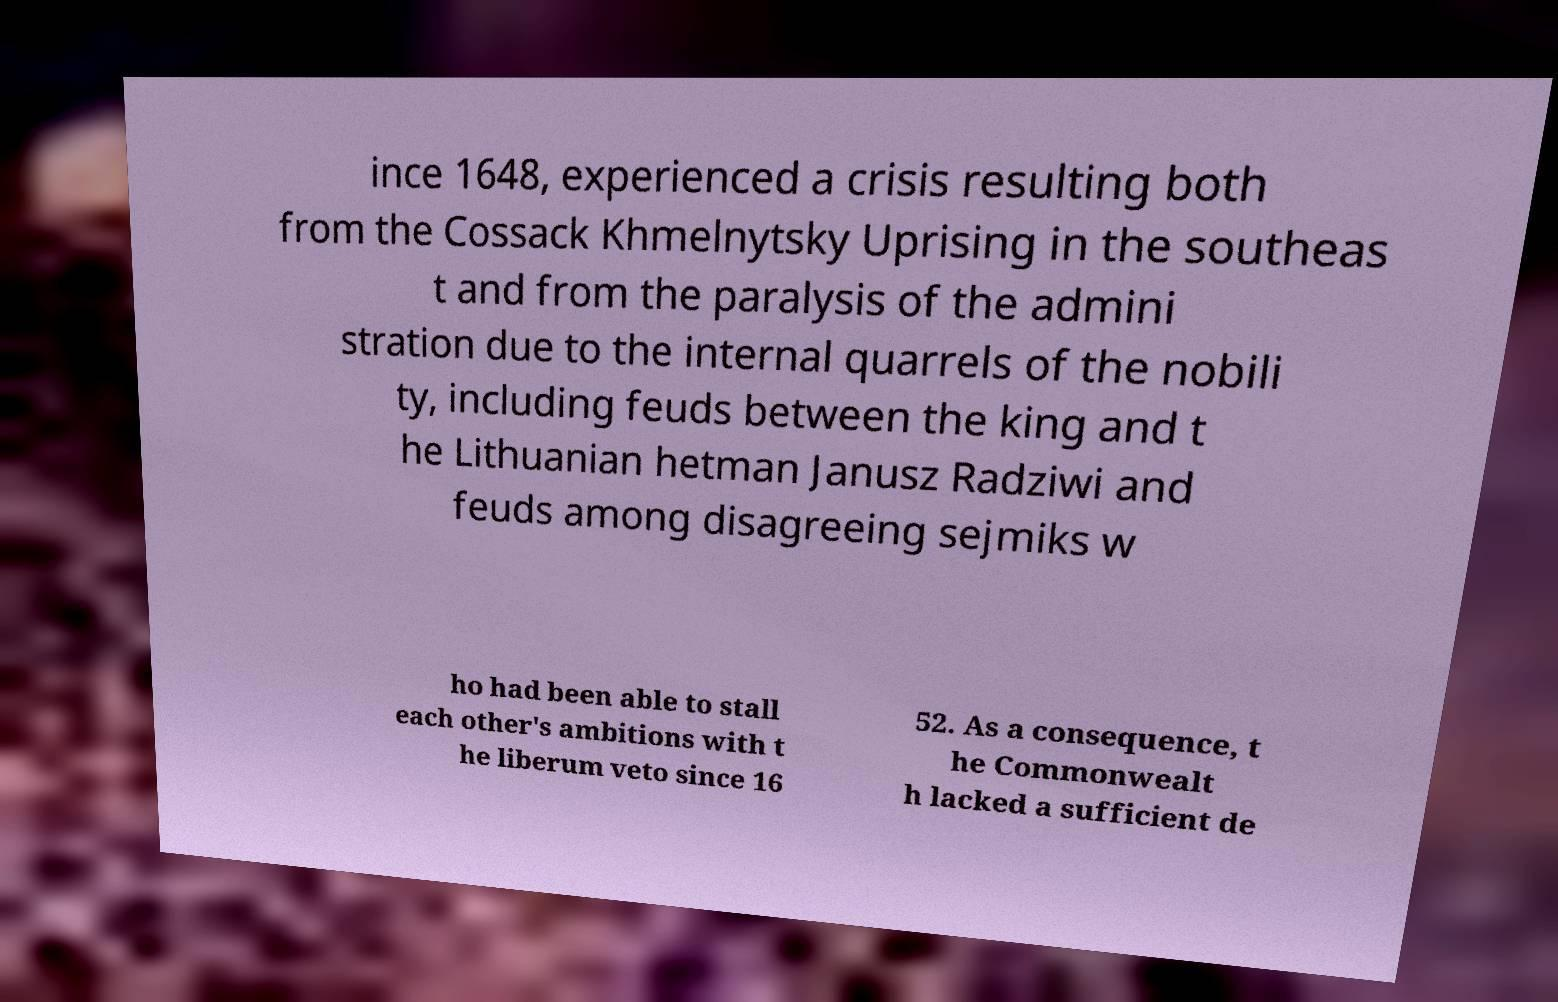Can you accurately transcribe the text from the provided image for me? ince 1648, experienced a crisis resulting both from the Cossack Khmelnytsky Uprising in the southeas t and from the paralysis of the admini stration due to the internal quarrels of the nobili ty, including feuds between the king and t he Lithuanian hetman Janusz Radziwi and feuds among disagreeing sejmiks w ho had been able to stall each other's ambitions with t he liberum veto since 16 52. As a consequence, t he Commonwealt h lacked a sufficient de 